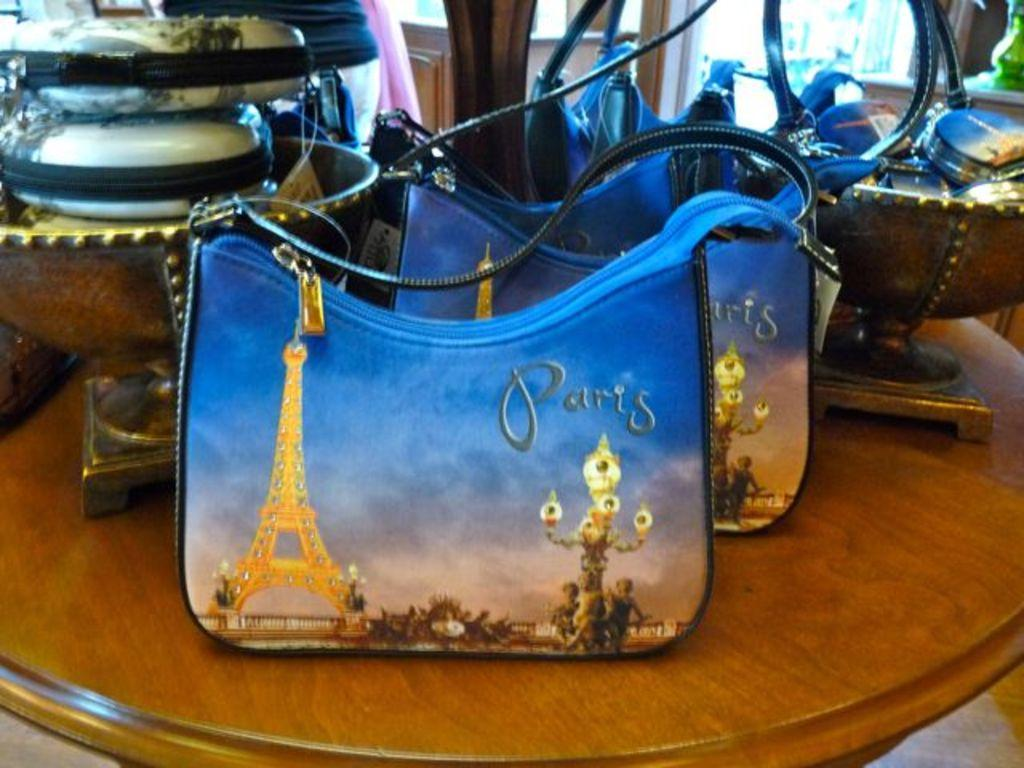What object is placed on the table in the image? There is a purse on the table. What else can be seen on the table in the image? There is a bowl on the table. How much profit does the mask in the image generate? There is no mask present in the image, so it is not possible to determine any profit generated. 